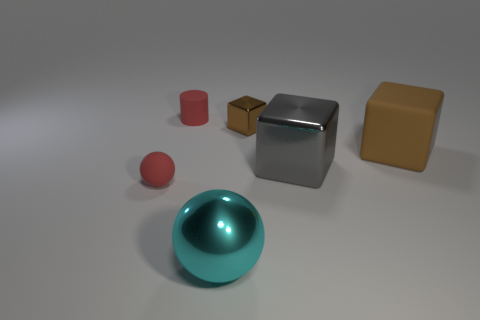Add 4 large cubes. How many objects exist? 10 Subtract all cylinders. How many objects are left? 5 Add 4 small red spheres. How many small red spheres are left? 5 Add 2 big purple shiny objects. How many big purple shiny objects exist? 2 Subtract 0 yellow cylinders. How many objects are left? 6 Subtract all tiny brown objects. Subtract all tiny rubber things. How many objects are left? 3 